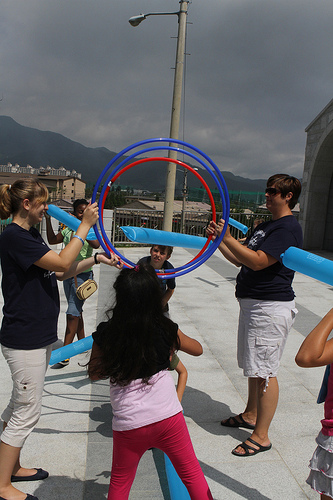<image>
Is the man behind the girl? Yes. From this viewpoint, the man is positioned behind the girl, with the girl partially or fully occluding the man. Is the rings behind the pole? No. The rings is not behind the pole. From this viewpoint, the rings appears to be positioned elsewhere in the scene. 